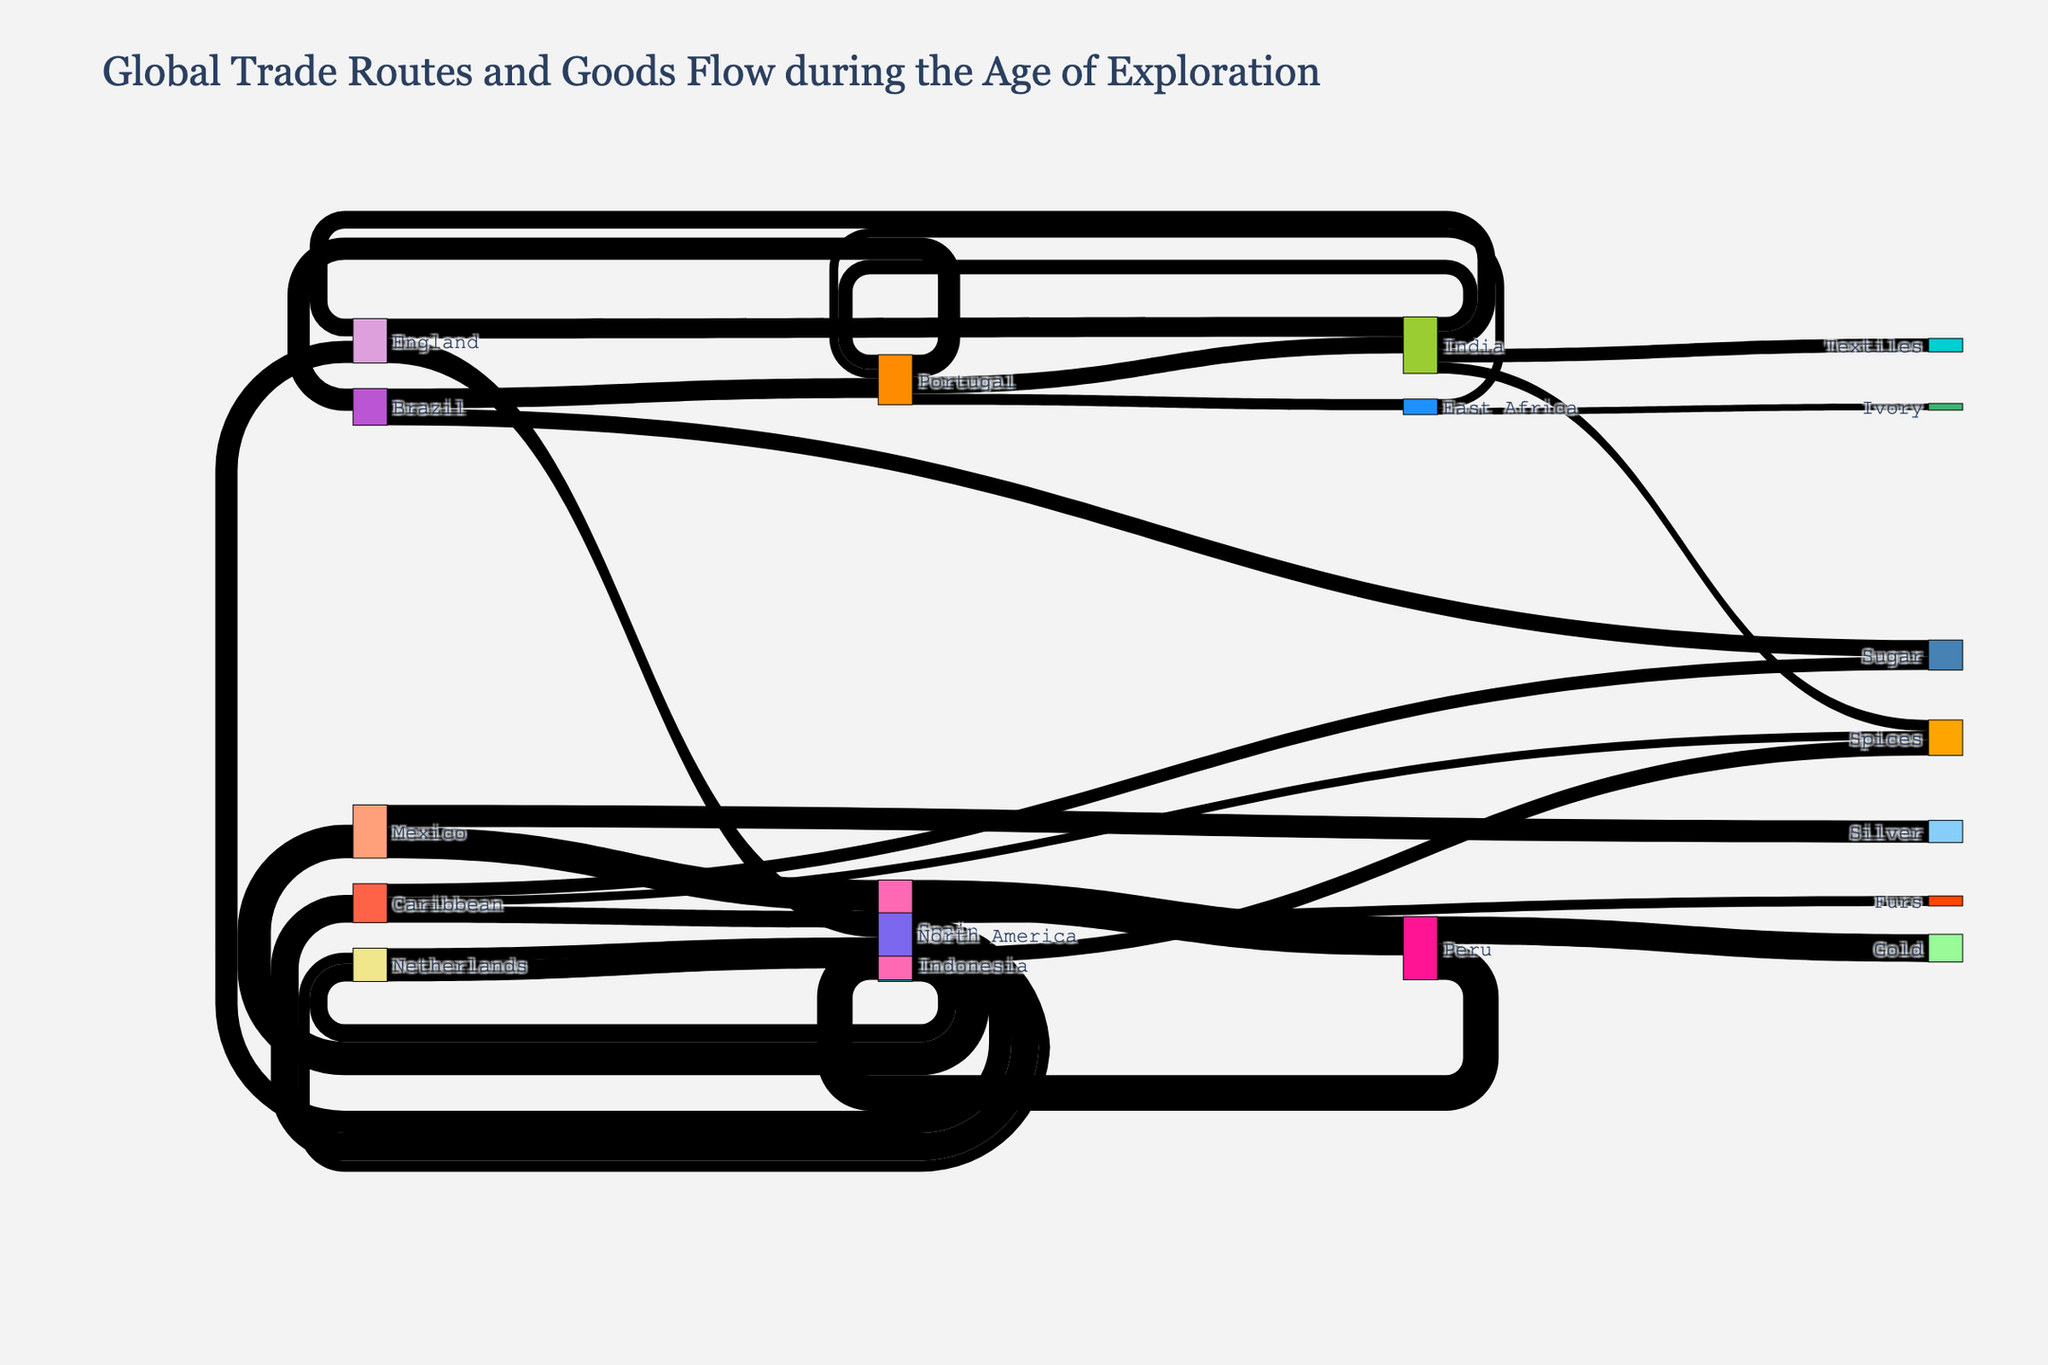What is the title of the Sankey Diagram? The title of the diagram is usually displayed prominently at the top of the figure.
Answer: Global Trade Routes and Goods Flow during the Age of Exploration How many nodes are present in the Sankey Diagram? Nodes represent the distinct points (sources and targets) in the diagram. By looking at the unique entities between sources and targets, you can count the nodes.
Answer: 20 Which region has the highest volume of trade coming from Spain? By observing the thickness of the flows originating from Spain, compare the values directed toward different regions.
Answer: Peru What is the total value of goods flowing from Portugal to its destinations? Sum the values of flows from Portugal to its various destinations: [Brazil, India, East Africa].
Answer: 450 Which item has the highest trade value coming from the Caribbean? Look at the flows originating from the Caribbean and compare the values associated with different items.
Answer: Sugar How does the trade volume from Spain to Mexico compare with the trade volume from Spain to the Caribbean? Compare the respective values of flows from Spain to these regions.
Answer: Spain to Mexico is higher From which region does Spain receive the largest volume of goods? Look at the flows directed toward Spain and identify the one with the highest value.
Answer: Peru What is the total value of goods flowing to Europe (Spain, Portugal, England, Netherlands)? Sum the total values directed towards these specific European regions.
Answer: 2180 Which European country has the most diverse trade routes? Identify which European country has the most number of different trade destinations.
Answer: Spain What is the value difference between the goods flowing from the Caribbean to Spain and the goods flowing from Mexico to Spain? Calculate the value difference by subtracting the value of goods flowing from the Caribbean to Spain from those flowing from Mexico to Spain.
Answer: 130 